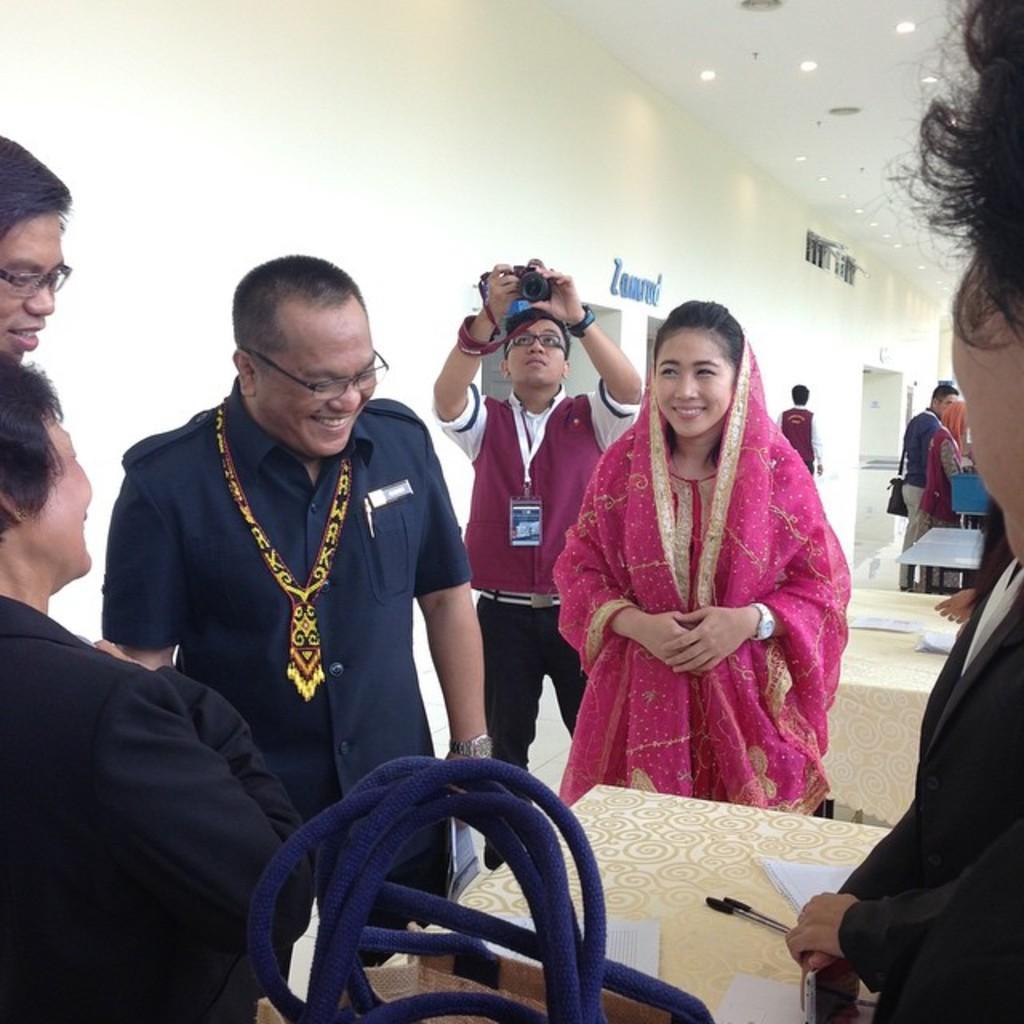Please provide a concise description of this image. In this picture I can see a few people with a smile standing on the surface. I can see a person holding the camera. I can see light arrangements on the roof. I can see the table. 